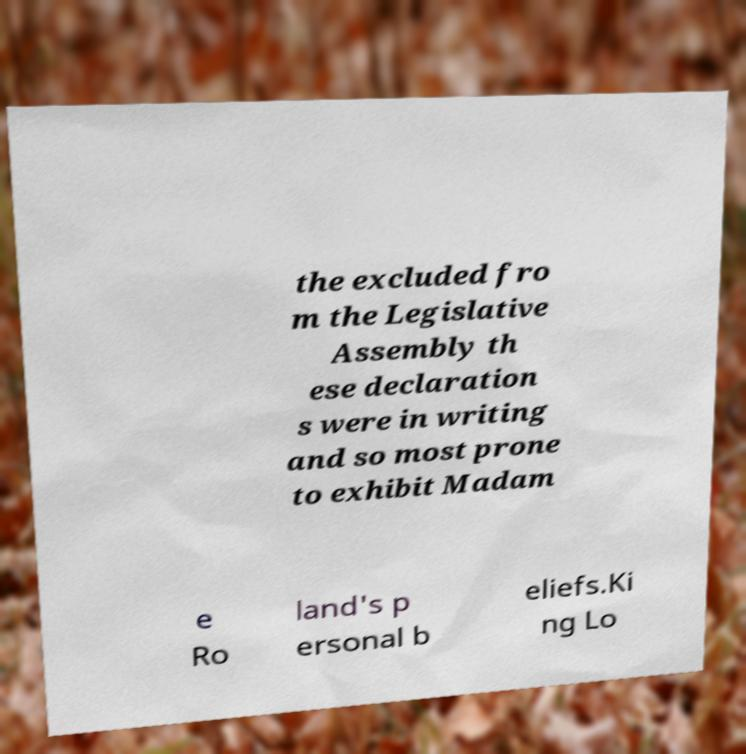Could you assist in decoding the text presented in this image and type it out clearly? the excluded fro m the Legislative Assembly th ese declaration s were in writing and so most prone to exhibit Madam e Ro land's p ersonal b eliefs.Ki ng Lo 